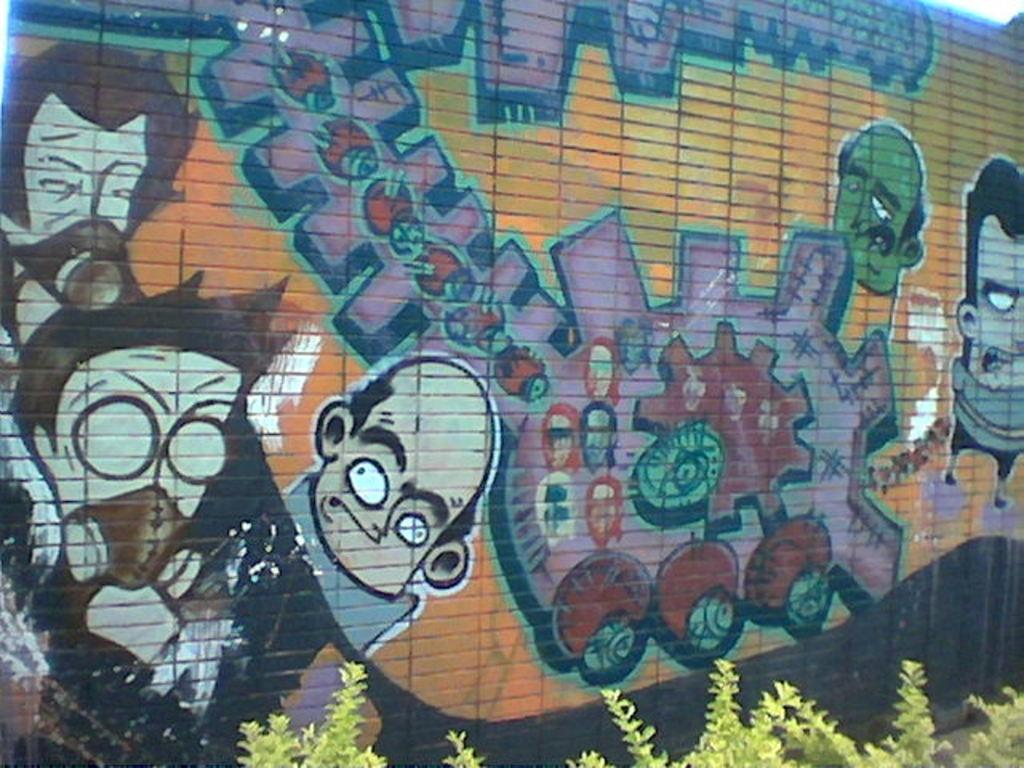What type of living organisms can be seen in the image? Plants can be seen in the image. What is present on the wall in the image? There is a painting on a wall in the image. What type of water is being used to clean the dad's shame in the image? There is no reference to water, dad, or shame in the image, so it is not possible to answer that question. 